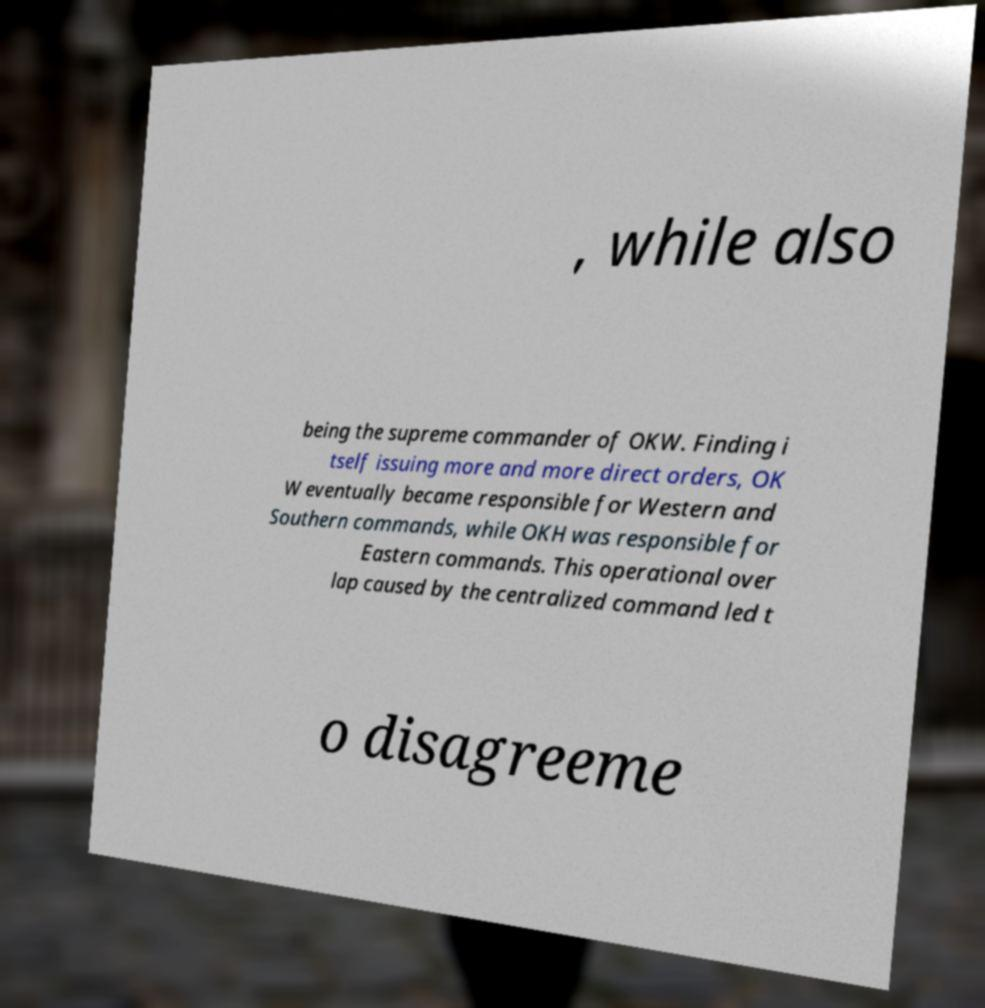Can you accurately transcribe the text from the provided image for me? , while also being the supreme commander of OKW. Finding i tself issuing more and more direct orders, OK W eventually became responsible for Western and Southern commands, while OKH was responsible for Eastern commands. This operational over lap caused by the centralized command led t o disagreeme 